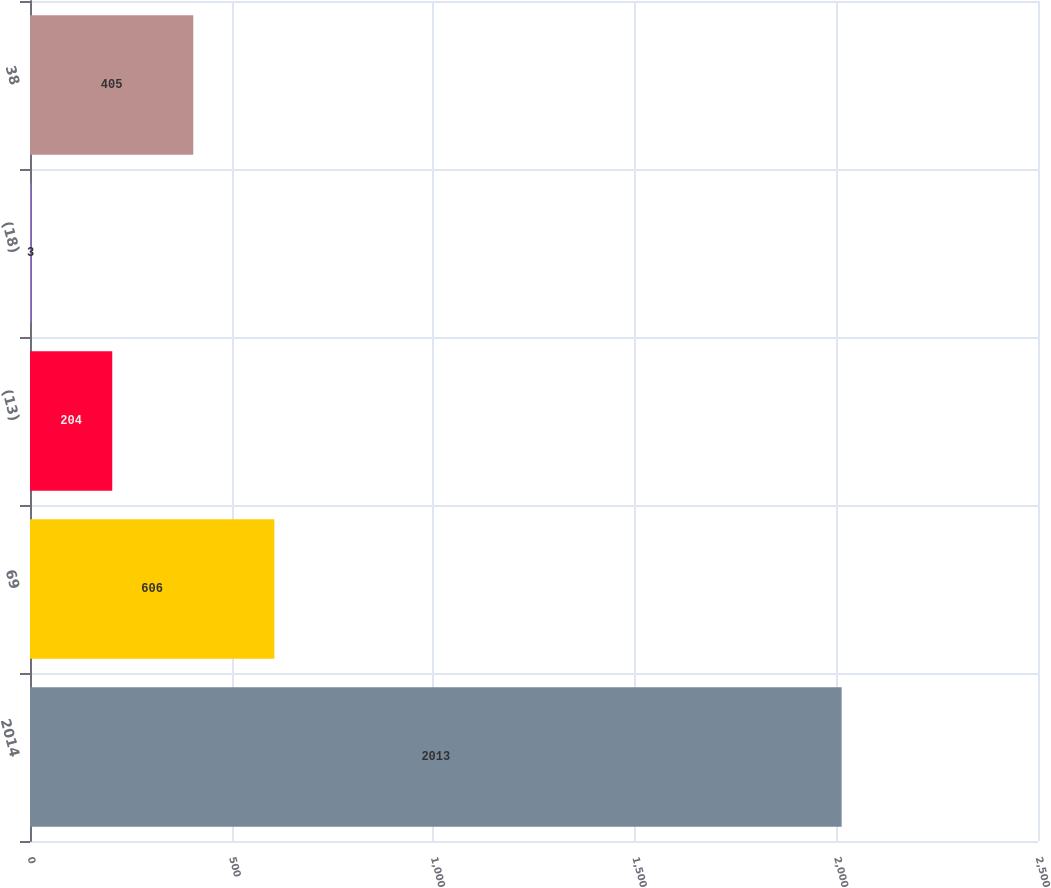Convert chart to OTSL. <chart><loc_0><loc_0><loc_500><loc_500><bar_chart><fcel>2014<fcel>69<fcel>(13)<fcel>(18)<fcel>38<nl><fcel>2013<fcel>606<fcel>204<fcel>3<fcel>405<nl></chart> 